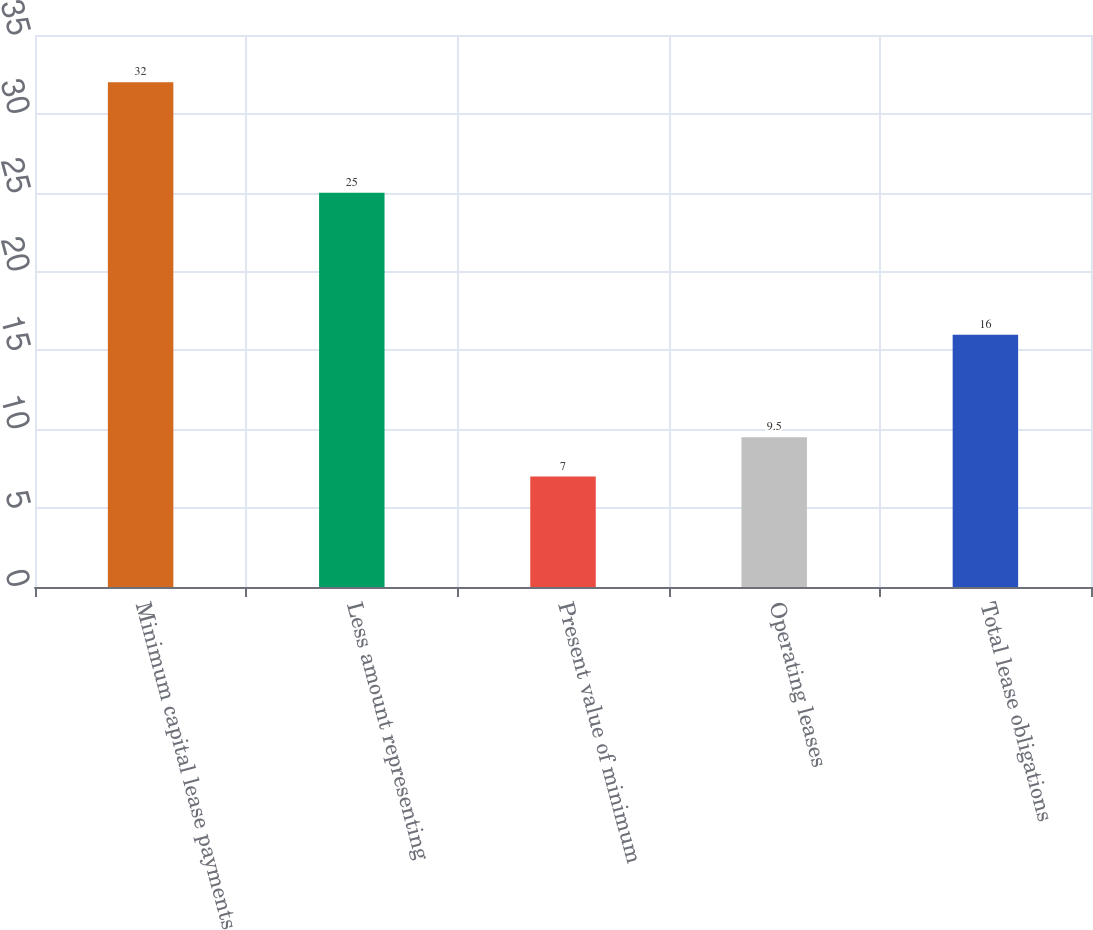Convert chart. <chart><loc_0><loc_0><loc_500><loc_500><bar_chart><fcel>Minimum capital lease payments<fcel>Less amount representing<fcel>Present value of minimum<fcel>Operating leases<fcel>Total lease obligations<nl><fcel>32<fcel>25<fcel>7<fcel>9.5<fcel>16<nl></chart> 